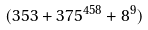Convert formula to latex. <formula><loc_0><loc_0><loc_500><loc_500>( 3 5 3 + 3 7 5 ^ { 4 5 8 } + 8 ^ { 9 } )</formula> 